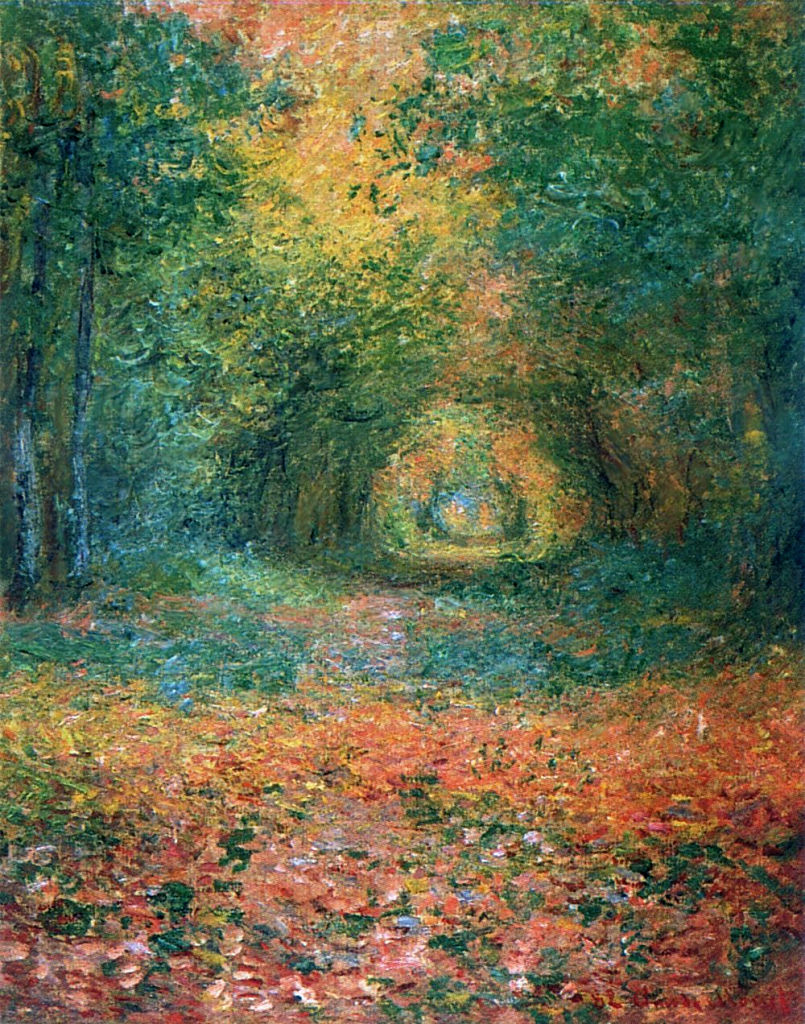How does the brushwork affect the viewer's perception of this scene? The brushwork in this Impressionist painting is loose and fluid, creating a dynamic texture that brings the forest to life. By deliberately blurring the lines and details, the artist encourages viewers to focus less on the specifics and more on the overall feel or atmosphere of the scene. This technique effectively conveys motion— such as wind rustling through leaves—and the ephemeral quality of natural light filtering through the trees, thus enhancing the viewer’s sensory experience of the painting as if they are actually strolling through this peaceful forest path. 